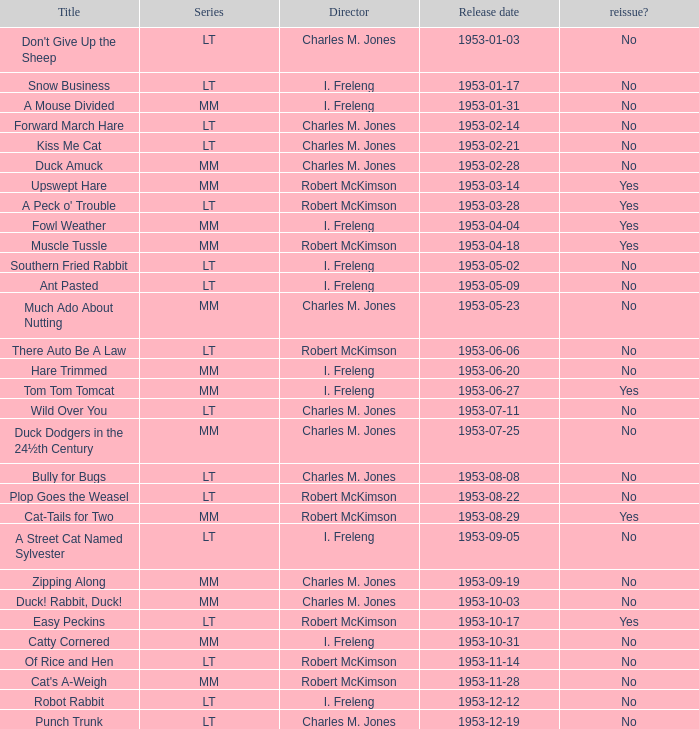I'm looking to parse the entire table for insights. Could you assist me with that? {'header': ['Title', 'Series', 'Director', 'Release date', 'reissue?'], 'rows': [["Don't Give Up the Sheep", 'LT', 'Charles M. Jones', '1953-01-03', 'No'], ['Snow Business', 'LT', 'I. Freleng', '1953-01-17', 'No'], ['A Mouse Divided', 'MM', 'I. Freleng', '1953-01-31', 'No'], ['Forward March Hare', 'LT', 'Charles M. Jones', '1953-02-14', 'No'], ['Kiss Me Cat', 'LT', 'Charles M. Jones', '1953-02-21', 'No'], ['Duck Amuck', 'MM', 'Charles M. Jones', '1953-02-28', 'No'], ['Upswept Hare', 'MM', 'Robert McKimson', '1953-03-14', 'Yes'], ["A Peck o' Trouble", 'LT', 'Robert McKimson', '1953-03-28', 'Yes'], ['Fowl Weather', 'MM', 'I. Freleng', '1953-04-04', 'Yes'], ['Muscle Tussle', 'MM', 'Robert McKimson', '1953-04-18', 'Yes'], ['Southern Fried Rabbit', 'LT', 'I. Freleng', '1953-05-02', 'No'], ['Ant Pasted', 'LT', 'I. Freleng', '1953-05-09', 'No'], ['Much Ado About Nutting', 'MM', 'Charles M. Jones', '1953-05-23', 'No'], ['There Auto Be A Law', 'LT', 'Robert McKimson', '1953-06-06', 'No'], ['Hare Trimmed', 'MM', 'I. Freleng', '1953-06-20', 'No'], ['Tom Tom Tomcat', 'MM', 'I. Freleng', '1953-06-27', 'Yes'], ['Wild Over You', 'LT', 'Charles M. Jones', '1953-07-11', 'No'], ['Duck Dodgers in the 24½th Century', 'MM', 'Charles M. Jones', '1953-07-25', 'No'], ['Bully for Bugs', 'LT', 'Charles M. Jones', '1953-08-08', 'No'], ['Plop Goes the Weasel', 'LT', 'Robert McKimson', '1953-08-22', 'No'], ['Cat-Tails for Two', 'MM', 'Robert McKimson', '1953-08-29', 'Yes'], ['A Street Cat Named Sylvester', 'LT', 'I. Freleng', '1953-09-05', 'No'], ['Zipping Along', 'MM', 'Charles M. Jones', '1953-09-19', 'No'], ['Duck! Rabbit, Duck!', 'MM', 'Charles M. Jones', '1953-10-03', 'No'], ['Easy Peckins', 'LT', 'Robert McKimson', '1953-10-17', 'Yes'], ['Catty Cornered', 'MM', 'I. Freleng', '1953-10-31', 'No'], ['Of Rice and Hen', 'LT', 'Robert McKimson', '1953-11-14', 'No'], ["Cat's A-Weigh", 'MM', 'Robert McKimson', '1953-11-28', 'No'], ['Robot Rabbit', 'LT', 'I. Freleng', '1953-12-12', 'No'], ['Punch Trunk', 'LT', 'Charles M. Jones', '1953-12-19', 'No']]} What's the series of Kiss Me Cat? LT. 